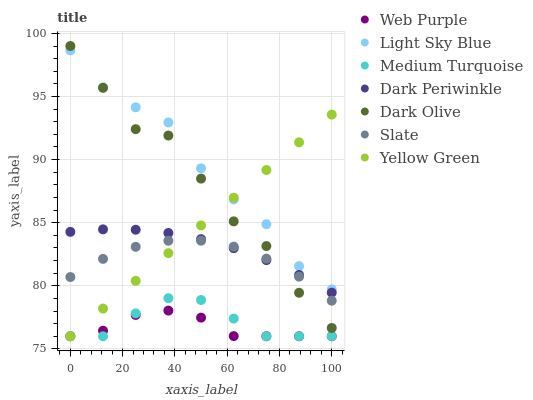Does Web Purple have the minimum area under the curve?
Answer yes or no. Yes. Does Light Sky Blue have the maximum area under the curve?
Answer yes or no. Yes. Does Slate have the minimum area under the curve?
Answer yes or no. No. Does Slate have the maximum area under the curve?
Answer yes or no. No. Is Yellow Green the smoothest?
Answer yes or no. Yes. Is Dark Olive the roughest?
Answer yes or no. Yes. Is Slate the smoothest?
Answer yes or no. No. Is Slate the roughest?
Answer yes or no. No. Does Yellow Green have the lowest value?
Answer yes or no. Yes. Does Slate have the lowest value?
Answer yes or no. No. Does Dark Olive have the highest value?
Answer yes or no. Yes. Does Slate have the highest value?
Answer yes or no. No. Is Dark Periwinkle less than Light Sky Blue?
Answer yes or no. Yes. Is Slate greater than Web Purple?
Answer yes or no. Yes. Does Dark Periwinkle intersect Slate?
Answer yes or no. Yes. Is Dark Periwinkle less than Slate?
Answer yes or no. No. Is Dark Periwinkle greater than Slate?
Answer yes or no. No. Does Dark Periwinkle intersect Light Sky Blue?
Answer yes or no. No. 